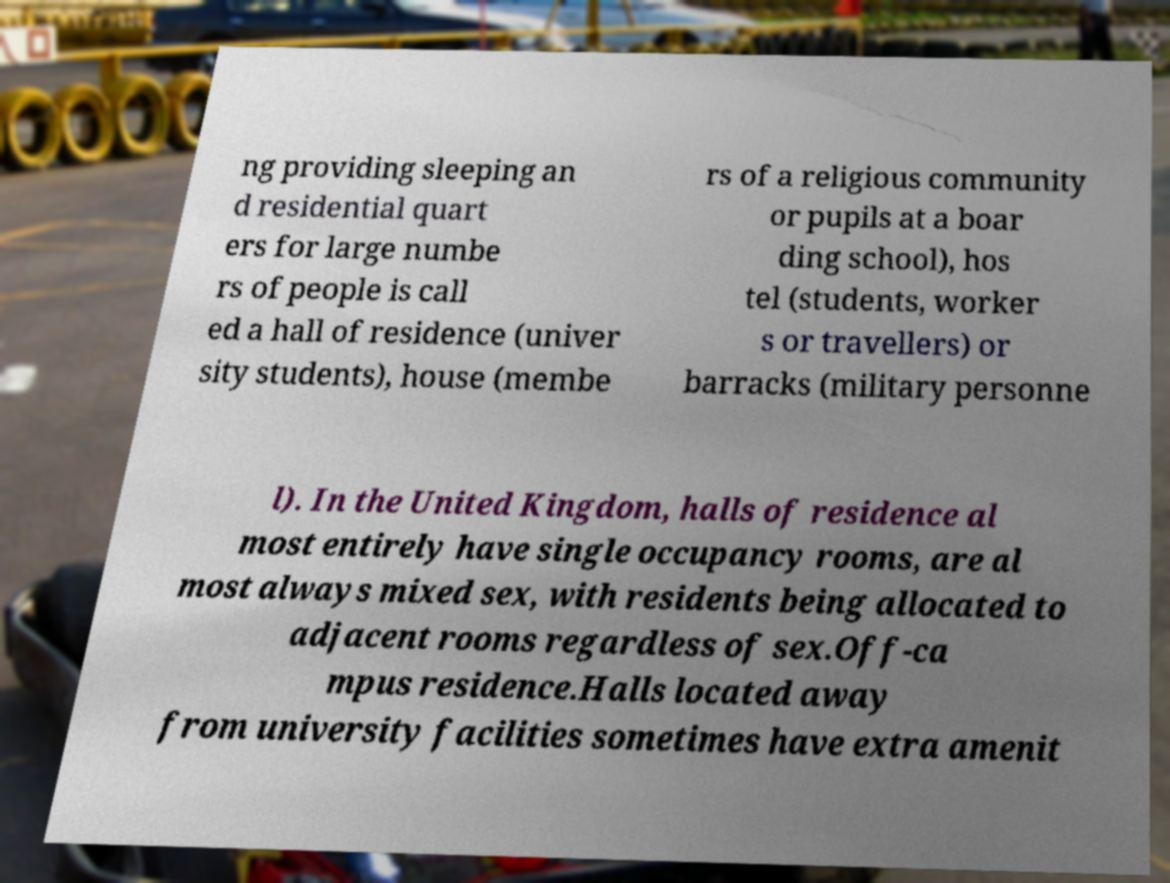For documentation purposes, I need the text within this image transcribed. Could you provide that? ng providing sleeping an d residential quart ers for large numbe rs of people is call ed a hall of residence (univer sity students), house (membe rs of a religious community or pupils at a boar ding school), hos tel (students, worker s or travellers) or barracks (military personne l). In the United Kingdom, halls of residence al most entirely have single occupancy rooms, are al most always mixed sex, with residents being allocated to adjacent rooms regardless of sex.Off-ca mpus residence.Halls located away from university facilities sometimes have extra amenit 